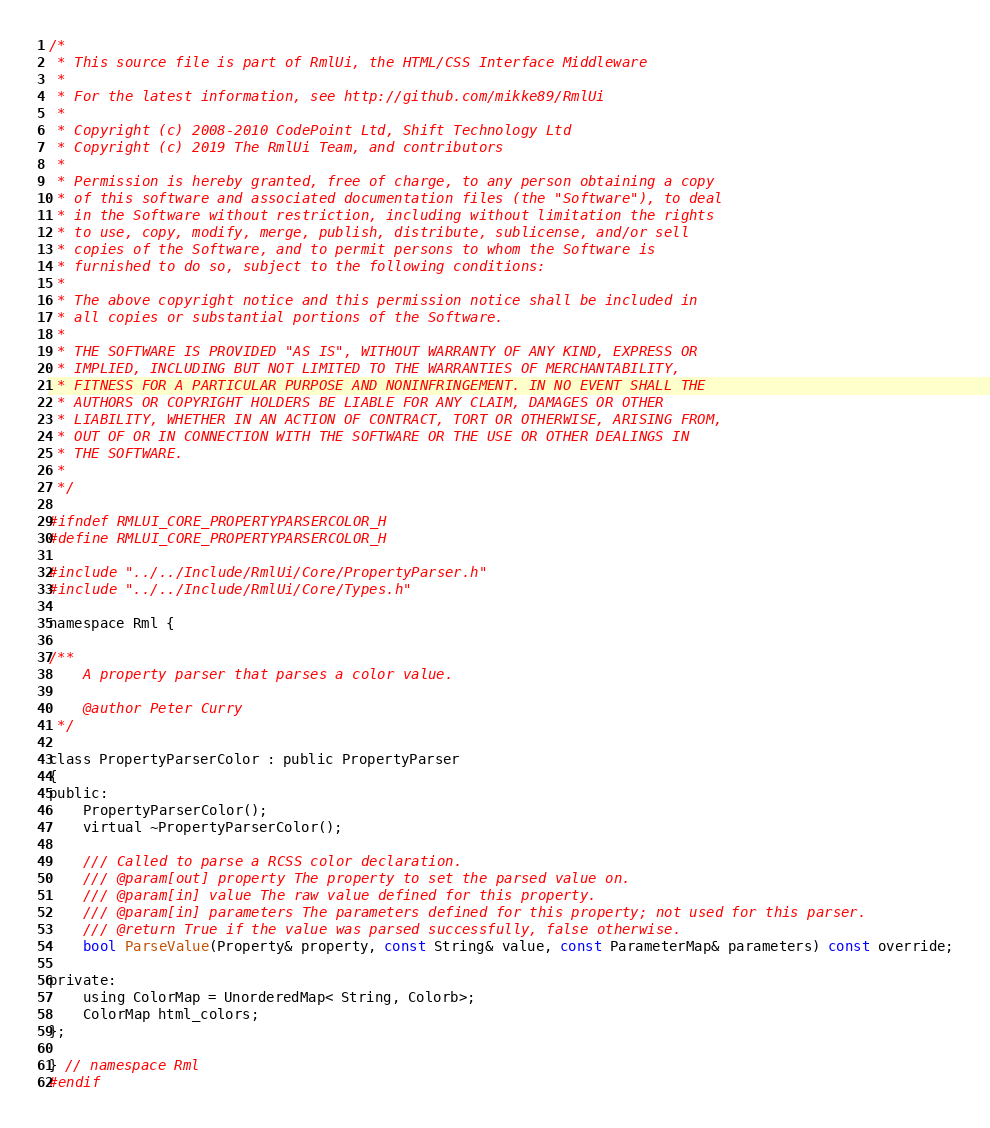<code> <loc_0><loc_0><loc_500><loc_500><_C_>/*
 * This source file is part of RmlUi, the HTML/CSS Interface Middleware
 *
 * For the latest information, see http://github.com/mikke89/RmlUi
 *
 * Copyright (c) 2008-2010 CodePoint Ltd, Shift Technology Ltd
 * Copyright (c) 2019 The RmlUi Team, and contributors
 *
 * Permission is hereby granted, free of charge, to any person obtaining a copy
 * of this software and associated documentation files (the "Software"), to deal
 * in the Software without restriction, including without limitation the rights
 * to use, copy, modify, merge, publish, distribute, sublicense, and/or sell
 * copies of the Software, and to permit persons to whom the Software is
 * furnished to do so, subject to the following conditions:
 *
 * The above copyright notice and this permission notice shall be included in
 * all copies or substantial portions of the Software.
 * 
 * THE SOFTWARE IS PROVIDED "AS IS", WITHOUT WARRANTY OF ANY KIND, EXPRESS OR
 * IMPLIED, INCLUDING BUT NOT LIMITED TO THE WARRANTIES OF MERCHANTABILITY,
 * FITNESS FOR A PARTICULAR PURPOSE AND NONINFRINGEMENT. IN NO EVENT SHALL THE
 * AUTHORS OR COPYRIGHT HOLDERS BE LIABLE FOR ANY CLAIM, DAMAGES OR OTHER
 * LIABILITY, WHETHER IN AN ACTION OF CONTRACT, TORT OR OTHERWISE, ARISING FROM,
 * OUT OF OR IN CONNECTION WITH THE SOFTWARE OR THE USE OR OTHER DEALINGS IN
 * THE SOFTWARE.
 *
 */

#ifndef RMLUI_CORE_PROPERTYPARSERCOLOR_H
#define RMLUI_CORE_PROPERTYPARSERCOLOR_H

#include "../../Include/RmlUi/Core/PropertyParser.h"
#include "../../Include/RmlUi/Core/Types.h"

namespace Rml {

/**
	A property parser that parses a color value.

	@author Peter Curry
 */

class PropertyParserColor : public PropertyParser
{
public:
	PropertyParserColor();
	virtual ~PropertyParserColor();

	/// Called to parse a RCSS color declaration.
	/// @param[out] property The property to set the parsed value on.
	/// @param[in] value The raw value defined for this property.
	/// @param[in] parameters The parameters defined for this property; not used for this parser.
	/// @return True if the value was parsed successfully, false otherwise.
	bool ParseValue(Property& property, const String& value, const ParameterMap& parameters) const override;

private:
	using ColorMap = UnorderedMap< String, Colorb>;
	ColorMap html_colors;
};

} // namespace Rml
#endif
</code> 